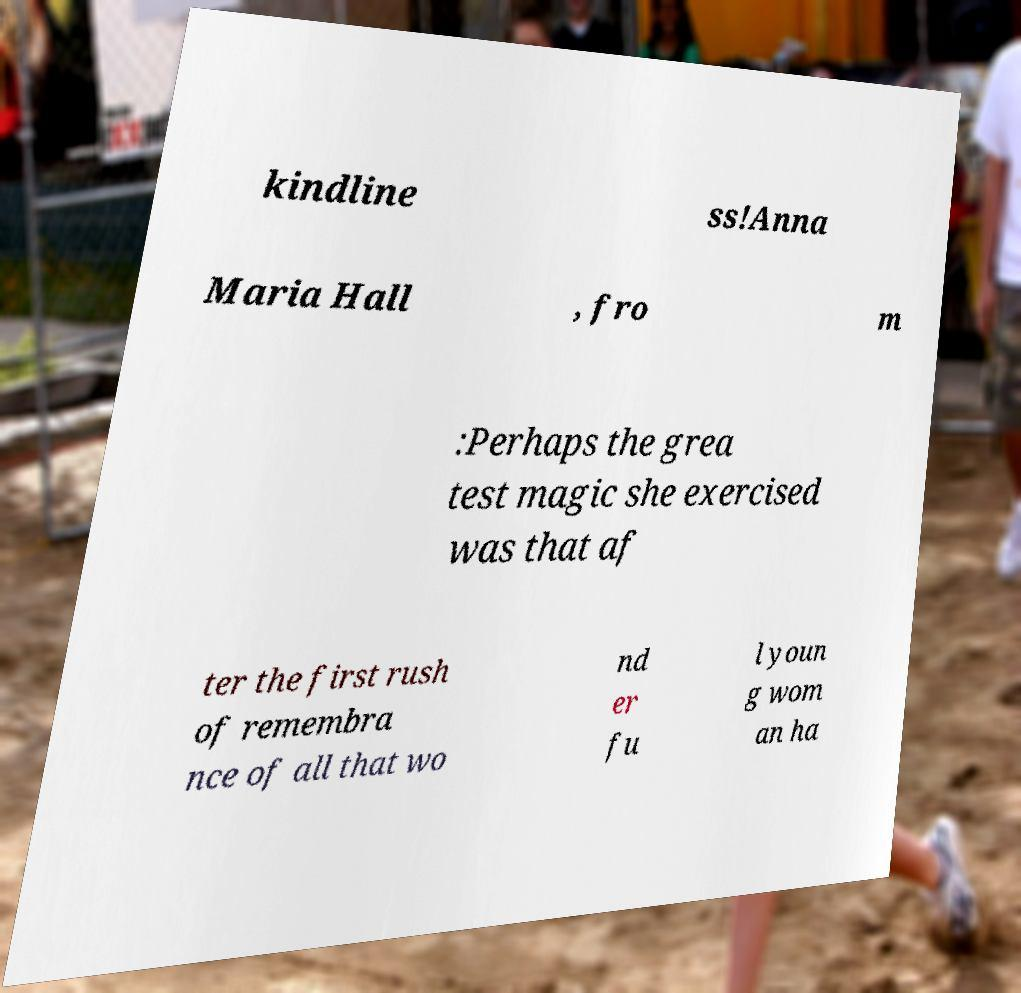Please identify and transcribe the text found in this image. kindline ss!Anna Maria Hall , fro m :Perhaps the grea test magic she exercised was that af ter the first rush of remembra nce of all that wo nd er fu l youn g wom an ha 